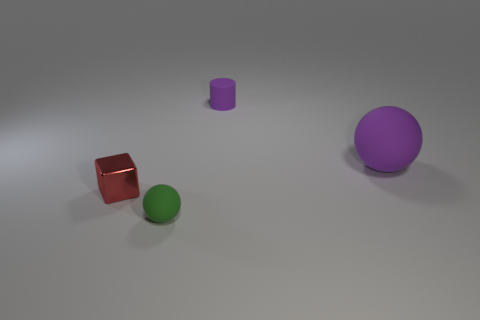The purple cylinder that is made of the same material as the small green thing is what size?
Provide a succinct answer. Small. How many cylinders are either red rubber objects or large purple objects?
Provide a short and direct response. 0. Are there more large red metallic blocks than matte things?
Your answer should be compact. No. What number of other purple spheres have the same size as the purple matte sphere?
Provide a short and direct response. 0. What is the shape of the big rubber thing that is the same color as the matte cylinder?
Make the answer very short. Sphere. What number of objects are tiny rubber things that are behind the green matte ball or cyan matte spheres?
Your response must be concise. 1. Are there fewer objects than matte cylinders?
Offer a terse response. No. There is a large purple object that is made of the same material as the small cylinder; what is its shape?
Keep it short and to the point. Sphere. There is a green rubber ball; are there any small red shiny things in front of it?
Provide a short and direct response. No. Is the number of small purple matte cylinders that are behind the purple matte cylinder less than the number of rubber cylinders?
Provide a succinct answer. Yes. 